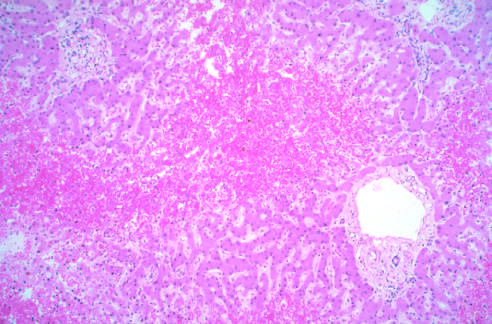re portal tracts and the periportal parenchyma intact?
Answer the question using a single word or phrase. Yes 